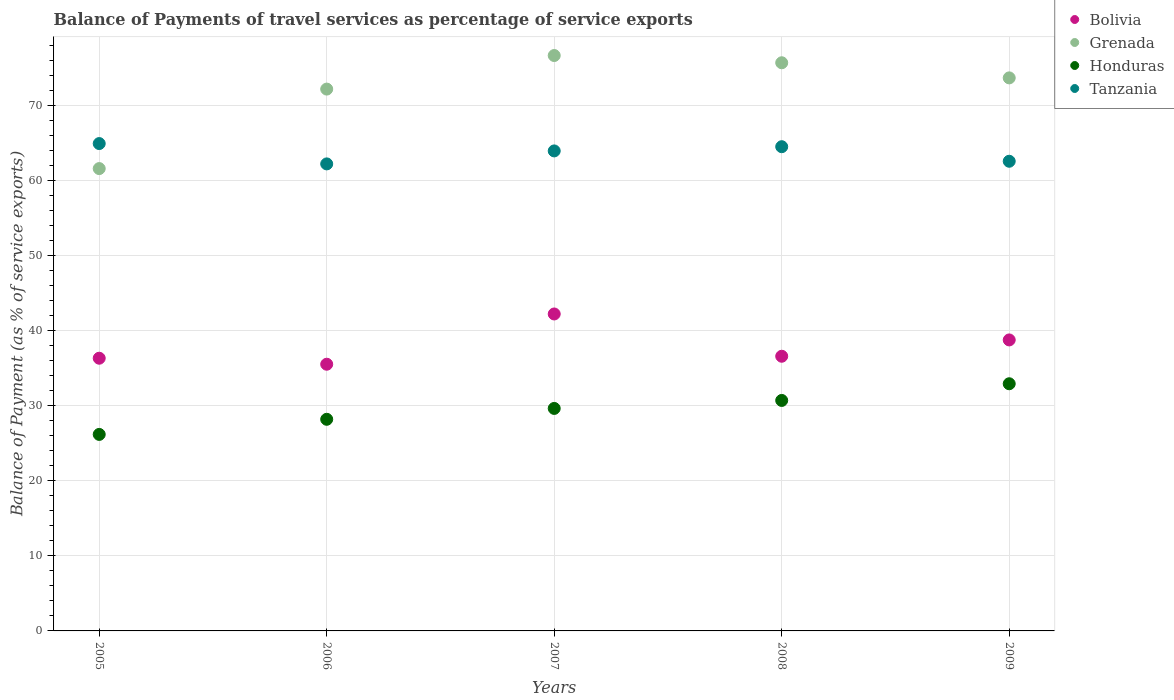What is the balance of payments of travel services in Bolivia in 2006?
Provide a short and direct response. 35.51. Across all years, what is the maximum balance of payments of travel services in Grenada?
Ensure brevity in your answer.  76.62. Across all years, what is the minimum balance of payments of travel services in Grenada?
Provide a short and direct response. 61.56. In which year was the balance of payments of travel services in Tanzania maximum?
Your answer should be very brief. 2005. In which year was the balance of payments of travel services in Honduras minimum?
Provide a short and direct response. 2005. What is the total balance of payments of travel services in Grenada in the graph?
Keep it short and to the point. 359.61. What is the difference between the balance of payments of travel services in Honduras in 2005 and that in 2008?
Keep it short and to the point. -4.52. What is the difference between the balance of payments of travel services in Honduras in 2006 and the balance of payments of travel services in Bolivia in 2005?
Provide a succinct answer. -8.13. What is the average balance of payments of travel services in Tanzania per year?
Provide a succinct answer. 63.6. In the year 2008, what is the difference between the balance of payments of travel services in Grenada and balance of payments of travel services in Honduras?
Ensure brevity in your answer.  44.96. What is the ratio of the balance of payments of travel services in Bolivia in 2006 to that in 2007?
Keep it short and to the point. 0.84. Is the balance of payments of travel services in Grenada in 2006 less than that in 2008?
Ensure brevity in your answer.  Yes. Is the difference between the balance of payments of travel services in Grenada in 2005 and 2006 greater than the difference between the balance of payments of travel services in Honduras in 2005 and 2006?
Your answer should be compact. No. What is the difference between the highest and the second highest balance of payments of travel services in Grenada?
Give a very brief answer. 0.96. What is the difference between the highest and the lowest balance of payments of travel services in Tanzania?
Your answer should be very brief. 2.71. Is the sum of the balance of payments of travel services in Grenada in 2006 and 2009 greater than the maximum balance of payments of travel services in Honduras across all years?
Give a very brief answer. Yes. Does the balance of payments of travel services in Bolivia monotonically increase over the years?
Provide a short and direct response. No. Is the balance of payments of travel services in Bolivia strictly greater than the balance of payments of travel services in Grenada over the years?
Your answer should be very brief. No. Is the balance of payments of travel services in Tanzania strictly less than the balance of payments of travel services in Honduras over the years?
Your response must be concise. No. How many dotlines are there?
Keep it short and to the point. 4. What is the difference between two consecutive major ticks on the Y-axis?
Keep it short and to the point. 10. Are the values on the major ticks of Y-axis written in scientific E-notation?
Ensure brevity in your answer.  No. Does the graph contain any zero values?
Keep it short and to the point. No. Does the graph contain grids?
Your response must be concise. Yes. Where does the legend appear in the graph?
Your answer should be very brief. Top right. How many legend labels are there?
Keep it short and to the point. 4. What is the title of the graph?
Ensure brevity in your answer.  Balance of Payments of travel services as percentage of service exports. What is the label or title of the Y-axis?
Provide a succinct answer. Balance of Payment (as % of service exports). What is the Balance of Payment (as % of service exports) in Bolivia in 2005?
Provide a succinct answer. 36.31. What is the Balance of Payment (as % of service exports) of Grenada in 2005?
Provide a succinct answer. 61.56. What is the Balance of Payment (as % of service exports) in Honduras in 2005?
Provide a short and direct response. 26.17. What is the Balance of Payment (as % of service exports) of Tanzania in 2005?
Make the answer very short. 64.89. What is the Balance of Payment (as % of service exports) in Bolivia in 2006?
Your answer should be compact. 35.51. What is the Balance of Payment (as % of service exports) of Grenada in 2006?
Ensure brevity in your answer.  72.14. What is the Balance of Payment (as % of service exports) in Honduras in 2006?
Make the answer very short. 28.18. What is the Balance of Payment (as % of service exports) in Tanzania in 2006?
Provide a succinct answer. 62.18. What is the Balance of Payment (as % of service exports) of Bolivia in 2007?
Give a very brief answer. 42.2. What is the Balance of Payment (as % of service exports) in Grenada in 2007?
Offer a terse response. 76.62. What is the Balance of Payment (as % of service exports) in Honduras in 2007?
Ensure brevity in your answer.  29.63. What is the Balance of Payment (as % of service exports) of Tanzania in 2007?
Provide a succinct answer. 63.91. What is the Balance of Payment (as % of service exports) of Bolivia in 2008?
Offer a terse response. 36.57. What is the Balance of Payment (as % of service exports) in Grenada in 2008?
Provide a short and direct response. 75.65. What is the Balance of Payment (as % of service exports) of Honduras in 2008?
Your answer should be compact. 30.69. What is the Balance of Payment (as % of service exports) of Tanzania in 2008?
Offer a terse response. 64.47. What is the Balance of Payment (as % of service exports) of Bolivia in 2009?
Your answer should be compact. 38.75. What is the Balance of Payment (as % of service exports) in Grenada in 2009?
Your answer should be compact. 73.64. What is the Balance of Payment (as % of service exports) in Honduras in 2009?
Make the answer very short. 32.91. What is the Balance of Payment (as % of service exports) in Tanzania in 2009?
Give a very brief answer. 62.54. Across all years, what is the maximum Balance of Payment (as % of service exports) of Bolivia?
Make the answer very short. 42.2. Across all years, what is the maximum Balance of Payment (as % of service exports) of Grenada?
Offer a terse response. 76.62. Across all years, what is the maximum Balance of Payment (as % of service exports) in Honduras?
Ensure brevity in your answer.  32.91. Across all years, what is the maximum Balance of Payment (as % of service exports) in Tanzania?
Give a very brief answer. 64.89. Across all years, what is the minimum Balance of Payment (as % of service exports) of Bolivia?
Offer a terse response. 35.51. Across all years, what is the minimum Balance of Payment (as % of service exports) in Grenada?
Give a very brief answer. 61.56. Across all years, what is the minimum Balance of Payment (as % of service exports) of Honduras?
Provide a short and direct response. 26.17. Across all years, what is the minimum Balance of Payment (as % of service exports) of Tanzania?
Your response must be concise. 62.18. What is the total Balance of Payment (as % of service exports) of Bolivia in the graph?
Offer a terse response. 189.34. What is the total Balance of Payment (as % of service exports) of Grenada in the graph?
Give a very brief answer. 359.61. What is the total Balance of Payment (as % of service exports) of Honduras in the graph?
Make the answer very short. 147.57. What is the total Balance of Payment (as % of service exports) in Tanzania in the graph?
Your answer should be very brief. 318. What is the difference between the Balance of Payment (as % of service exports) in Bolivia in 2005 and that in 2006?
Your answer should be very brief. 0.8. What is the difference between the Balance of Payment (as % of service exports) in Grenada in 2005 and that in 2006?
Your answer should be compact. -10.58. What is the difference between the Balance of Payment (as % of service exports) of Honduras in 2005 and that in 2006?
Offer a very short reply. -2.01. What is the difference between the Balance of Payment (as % of service exports) in Tanzania in 2005 and that in 2006?
Your answer should be compact. 2.71. What is the difference between the Balance of Payment (as % of service exports) of Bolivia in 2005 and that in 2007?
Your response must be concise. -5.89. What is the difference between the Balance of Payment (as % of service exports) in Grenada in 2005 and that in 2007?
Offer a terse response. -15.05. What is the difference between the Balance of Payment (as % of service exports) in Honduras in 2005 and that in 2007?
Your response must be concise. -3.46. What is the difference between the Balance of Payment (as % of service exports) of Tanzania in 2005 and that in 2007?
Make the answer very short. 0.98. What is the difference between the Balance of Payment (as % of service exports) in Bolivia in 2005 and that in 2008?
Provide a short and direct response. -0.26. What is the difference between the Balance of Payment (as % of service exports) of Grenada in 2005 and that in 2008?
Your answer should be very brief. -14.09. What is the difference between the Balance of Payment (as % of service exports) of Honduras in 2005 and that in 2008?
Offer a very short reply. -4.52. What is the difference between the Balance of Payment (as % of service exports) of Tanzania in 2005 and that in 2008?
Make the answer very short. 0.42. What is the difference between the Balance of Payment (as % of service exports) in Bolivia in 2005 and that in 2009?
Your response must be concise. -2.44. What is the difference between the Balance of Payment (as % of service exports) of Grenada in 2005 and that in 2009?
Offer a terse response. -12.08. What is the difference between the Balance of Payment (as % of service exports) in Honduras in 2005 and that in 2009?
Give a very brief answer. -6.75. What is the difference between the Balance of Payment (as % of service exports) in Tanzania in 2005 and that in 2009?
Ensure brevity in your answer.  2.36. What is the difference between the Balance of Payment (as % of service exports) in Bolivia in 2006 and that in 2007?
Your response must be concise. -6.69. What is the difference between the Balance of Payment (as % of service exports) of Grenada in 2006 and that in 2007?
Your response must be concise. -4.47. What is the difference between the Balance of Payment (as % of service exports) of Honduras in 2006 and that in 2007?
Offer a terse response. -1.45. What is the difference between the Balance of Payment (as % of service exports) in Tanzania in 2006 and that in 2007?
Make the answer very short. -1.73. What is the difference between the Balance of Payment (as % of service exports) of Bolivia in 2006 and that in 2008?
Offer a terse response. -1.06. What is the difference between the Balance of Payment (as % of service exports) in Grenada in 2006 and that in 2008?
Keep it short and to the point. -3.51. What is the difference between the Balance of Payment (as % of service exports) of Honduras in 2006 and that in 2008?
Your response must be concise. -2.51. What is the difference between the Balance of Payment (as % of service exports) in Tanzania in 2006 and that in 2008?
Your response must be concise. -2.29. What is the difference between the Balance of Payment (as % of service exports) of Bolivia in 2006 and that in 2009?
Make the answer very short. -3.24. What is the difference between the Balance of Payment (as % of service exports) in Grenada in 2006 and that in 2009?
Provide a short and direct response. -1.49. What is the difference between the Balance of Payment (as % of service exports) in Honduras in 2006 and that in 2009?
Ensure brevity in your answer.  -4.73. What is the difference between the Balance of Payment (as % of service exports) of Tanzania in 2006 and that in 2009?
Your response must be concise. -0.35. What is the difference between the Balance of Payment (as % of service exports) of Bolivia in 2007 and that in 2008?
Make the answer very short. 5.63. What is the difference between the Balance of Payment (as % of service exports) in Grenada in 2007 and that in 2008?
Give a very brief answer. 0.96. What is the difference between the Balance of Payment (as % of service exports) of Honduras in 2007 and that in 2008?
Make the answer very short. -1.06. What is the difference between the Balance of Payment (as % of service exports) in Tanzania in 2007 and that in 2008?
Your answer should be compact. -0.56. What is the difference between the Balance of Payment (as % of service exports) in Bolivia in 2007 and that in 2009?
Your answer should be compact. 3.46. What is the difference between the Balance of Payment (as % of service exports) of Grenada in 2007 and that in 2009?
Give a very brief answer. 2.98. What is the difference between the Balance of Payment (as % of service exports) in Honduras in 2007 and that in 2009?
Provide a succinct answer. -3.29. What is the difference between the Balance of Payment (as % of service exports) of Tanzania in 2007 and that in 2009?
Your response must be concise. 1.38. What is the difference between the Balance of Payment (as % of service exports) of Bolivia in 2008 and that in 2009?
Provide a succinct answer. -2.17. What is the difference between the Balance of Payment (as % of service exports) of Grenada in 2008 and that in 2009?
Your answer should be very brief. 2.01. What is the difference between the Balance of Payment (as % of service exports) in Honduras in 2008 and that in 2009?
Your answer should be very brief. -2.22. What is the difference between the Balance of Payment (as % of service exports) in Tanzania in 2008 and that in 2009?
Provide a succinct answer. 1.94. What is the difference between the Balance of Payment (as % of service exports) of Bolivia in 2005 and the Balance of Payment (as % of service exports) of Grenada in 2006?
Provide a short and direct response. -35.83. What is the difference between the Balance of Payment (as % of service exports) of Bolivia in 2005 and the Balance of Payment (as % of service exports) of Honduras in 2006?
Make the answer very short. 8.13. What is the difference between the Balance of Payment (as % of service exports) in Bolivia in 2005 and the Balance of Payment (as % of service exports) in Tanzania in 2006?
Offer a terse response. -25.87. What is the difference between the Balance of Payment (as % of service exports) of Grenada in 2005 and the Balance of Payment (as % of service exports) of Honduras in 2006?
Offer a terse response. 33.38. What is the difference between the Balance of Payment (as % of service exports) of Grenada in 2005 and the Balance of Payment (as % of service exports) of Tanzania in 2006?
Ensure brevity in your answer.  -0.62. What is the difference between the Balance of Payment (as % of service exports) of Honduras in 2005 and the Balance of Payment (as % of service exports) of Tanzania in 2006?
Give a very brief answer. -36.02. What is the difference between the Balance of Payment (as % of service exports) of Bolivia in 2005 and the Balance of Payment (as % of service exports) of Grenada in 2007?
Your response must be concise. -40.3. What is the difference between the Balance of Payment (as % of service exports) in Bolivia in 2005 and the Balance of Payment (as % of service exports) in Honduras in 2007?
Make the answer very short. 6.69. What is the difference between the Balance of Payment (as % of service exports) in Bolivia in 2005 and the Balance of Payment (as % of service exports) in Tanzania in 2007?
Ensure brevity in your answer.  -27.6. What is the difference between the Balance of Payment (as % of service exports) of Grenada in 2005 and the Balance of Payment (as % of service exports) of Honduras in 2007?
Ensure brevity in your answer.  31.94. What is the difference between the Balance of Payment (as % of service exports) of Grenada in 2005 and the Balance of Payment (as % of service exports) of Tanzania in 2007?
Provide a succinct answer. -2.35. What is the difference between the Balance of Payment (as % of service exports) in Honduras in 2005 and the Balance of Payment (as % of service exports) in Tanzania in 2007?
Give a very brief answer. -37.75. What is the difference between the Balance of Payment (as % of service exports) in Bolivia in 2005 and the Balance of Payment (as % of service exports) in Grenada in 2008?
Your response must be concise. -39.34. What is the difference between the Balance of Payment (as % of service exports) of Bolivia in 2005 and the Balance of Payment (as % of service exports) of Honduras in 2008?
Provide a succinct answer. 5.62. What is the difference between the Balance of Payment (as % of service exports) of Bolivia in 2005 and the Balance of Payment (as % of service exports) of Tanzania in 2008?
Provide a short and direct response. -28.16. What is the difference between the Balance of Payment (as % of service exports) in Grenada in 2005 and the Balance of Payment (as % of service exports) in Honduras in 2008?
Make the answer very short. 30.87. What is the difference between the Balance of Payment (as % of service exports) in Grenada in 2005 and the Balance of Payment (as % of service exports) in Tanzania in 2008?
Offer a terse response. -2.91. What is the difference between the Balance of Payment (as % of service exports) of Honduras in 2005 and the Balance of Payment (as % of service exports) of Tanzania in 2008?
Offer a very short reply. -38.31. What is the difference between the Balance of Payment (as % of service exports) in Bolivia in 2005 and the Balance of Payment (as % of service exports) in Grenada in 2009?
Ensure brevity in your answer.  -37.33. What is the difference between the Balance of Payment (as % of service exports) in Bolivia in 2005 and the Balance of Payment (as % of service exports) in Honduras in 2009?
Provide a short and direct response. 3.4. What is the difference between the Balance of Payment (as % of service exports) in Bolivia in 2005 and the Balance of Payment (as % of service exports) in Tanzania in 2009?
Your answer should be very brief. -26.23. What is the difference between the Balance of Payment (as % of service exports) in Grenada in 2005 and the Balance of Payment (as % of service exports) in Honduras in 2009?
Provide a short and direct response. 28.65. What is the difference between the Balance of Payment (as % of service exports) of Grenada in 2005 and the Balance of Payment (as % of service exports) of Tanzania in 2009?
Make the answer very short. -0.98. What is the difference between the Balance of Payment (as % of service exports) of Honduras in 2005 and the Balance of Payment (as % of service exports) of Tanzania in 2009?
Your answer should be compact. -36.37. What is the difference between the Balance of Payment (as % of service exports) in Bolivia in 2006 and the Balance of Payment (as % of service exports) in Grenada in 2007?
Your answer should be very brief. -41.1. What is the difference between the Balance of Payment (as % of service exports) of Bolivia in 2006 and the Balance of Payment (as % of service exports) of Honduras in 2007?
Offer a terse response. 5.89. What is the difference between the Balance of Payment (as % of service exports) in Bolivia in 2006 and the Balance of Payment (as % of service exports) in Tanzania in 2007?
Make the answer very short. -28.4. What is the difference between the Balance of Payment (as % of service exports) in Grenada in 2006 and the Balance of Payment (as % of service exports) in Honduras in 2007?
Offer a terse response. 42.52. What is the difference between the Balance of Payment (as % of service exports) in Grenada in 2006 and the Balance of Payment (as % of service exports) in Tanzania in 2007?
Provide a short and direct response. 8.23. What is the difference between the Balance of Payment (as % of service exports) in Honduras in 2006 and the Balance of Payment (as % of service exports) in Tanzania in 2007?
Ensure brevity in your answer.  -35.73. What is the difference between the Balance of Payment (as % of service exports) of Bolivia in 2006 and the Balance of Payment (as % of service exports) of Grenada in 2008?
Ensure brevity in your answer.  -40.14. What is the difference between the Balance of Payment (as % of service exports) of Bolivia in 2006 and the Balance of Payment (as % of service exports) of Honduras in 2008?
Your answer should be very brief. 4.82. What is the difference between the Balance of Payment (as % of service exports) of Bolivia in 2006 and the Balance of Payment (as % of service exports) of Tanzania in 2008?
Give a very brief answer. -28.96. What is the difference between the Balance of Payment (as % of service exports) in Grenada in 2006 and the Balance of Payment (as % of service exports) in Honduras in 2008?
Provide a short and direct response. 41.46. What is the difference between the Balance of Payment (as % of service exports) in Grenada in 2006 and the Balance of Payment (as % of service exports) in Tanzania in 2008?
Provide a short and direct response. 7.67. What is the difference between the Balance of Payment (as % of service exports) of Honduras in 2006 and the Balance of Payment (as % of service exports) of Tanzania in 2008?
Make the answer very short. -36.3. What is the difference between the Balance of Payment (as % of service exports) of Bolivia in 2006 and the Balance of Payment (as % of service exports) of Grenada in 2009?
Offer a terse response. -38.13. What is the difference between the Balance of Payment (as % of service exports) in Bolivia in 2006 and the Balance of Payment (as % of service exports) in Honduras in 2009?
Give a very brief answer. 2.6. What is the difference between the Balance of Payment (as % of service exports) in Bolivia in 2006 and the Balance of Payment (as % of service exports) in Tanzania in 2009?
Your answer should be very brief. -27.03. What is the difference between the Balance of Payment (as % of service exports) in Grenada in 2006 and the Balance of Payment (as % of service exports) in Honduras in 2009?
Give a very brief answer. 39.23. What is the difference between the Balance of Payment (as % of service exports) in Grenada in 2006 and the Balance of Payment (as % of service exports) in Tanzania in 2009?
Offer a very short reply. 9.61. What is the difference between the Balance of Payment (as % of service exports) of Honduras in 2006 and the Balance of Payment (as % of service exports) of Tanzania in 2009?
Your response must be concise. -34.36. What is the difference between the Balance of Payment (as % of service exports) in Bolivia in 2007 and the Balance of Payment (as % of service exports) in Grenada in 2008?
Keep it short and to the point. -33.45. What is the difference between the Balance of Payment (as % of service exports) in Bolivia in 2007 and the Balance of Payment (as % of service exports) in Honduras in 2008?
Make the answer very short. 11.51. What is the difference between the Balance of Payment (as % of service exports) of Bolivia in 2007 and the Balance of Payment (as % of service exports) of Tanzania in 2008?
Offer a terse response. -22.27. What is the difference between the Balance of Payment (as % of service exports) of Grenada in 2007 and the Balance of Payment (as % of service exports) of Honduras in 2008?
Your response must be concise. 45.93. What is the difference between the Balance of Payment (as % of service exports) in Grenada in 2007 and the Balance of Payment (as % of service exports) in Tanzania in 2008?
Offer a very short reply. 12.14. What is the difference between the Balance of Payment (as % of service exports) in Honduras in 2007 and the Balance of Payment (as % of service exports) in Tanzania in 2008?
Ensure brevity in your answer.  -34.85. What is the difference between the Balance of Payment (as % of service exports) of Bolivia in 2007 and the Balance of Payment (as % of service exports) of Grenada in 2009?
Offer a very short reply. -31.44. What is the difference between the Balance of Payment (as % of service exports) in Bolivia in 2007 and the Balance of Payment (as % of service exports) in Honduras in 2009?
Give a very brief answer. 9.29. What is the difference between the Balance of Payment (as % of service exports) in Bolivia in 2007 and the Balance of Payment (as % of service exports) in Tanzania in 2009?
Provide a short and direct response. -20.33. What is the difference between the Balance of Payment (as % of service exports) in Grenada in 2007 and the Balance of Payment (as % of service exports) in Honduras in 2009?
Offer a terse response. 43.7. What is the difference between the Balance of Payment (as % of service exports) of Grenada in 2007 and the Balance of Payment (as % of service exports) of Tanzania in 2009?
Your answer should be compact. 14.08. What is the difference between the Balance of Payment (as % of service exports) of Honduras in 2007 and the Balance of Payment (as % of service exports) of Tanzania in 2009?
Provide a short and direct response. -32.91. What is the difference between the Balance of Payment (as % of service exports) in Bolivia in 2008 and the Balance of Payment (as % of service exports) in Grenada in 2009?
Offer a terse response. -37.06. What is the difference between the Balance of Payment (as % of service exports) of Bolivia in 2008 and the Balance of Payment (as % of service exports) of Honduras in 2009?
Provide a succinct answer. 3.66. What is the difference between the Balance of Payment (as % of service exports) of Bolivia in 2008 and the Balance of Payment (as % of service exports) of Tanzania in 2009?
Your answer should be very brief. -25.96. What is the difference between the Balance of Payment (as % of service exports) in Grenada in 2008 and the Balance of Payment (as % of service exports) in Honduras in 2009?
Your answer should be compact. 42.74. What is the difference between the Balance of Payment (as % of service exports) of Grenada in 2008 and the Balance of Payment (as % of service exports) of Tanzania in 2009?
Offer a very short reply. 13.11. What is the difference between the Balance of Payment (as % of service exports) in Honduras in 2008 and the Balance of Payment (as % of service exports) in Tanzania in 2009?
Your answer should be very brief. -31.85. What is the average Balance of Payment (as % of service exports) in Bolivia per year?
Your response must be concise. 37.87. What is the average Balance of Payment (as % of service exports) in Grenada per year?
Your response must be concise. 71.92. What is the average Balance of Payment (as % of service exports) in Honduras per year?
Your response must be concise. 29.51. What is the average Balance of Payment (as % of service exports) of Tanzania per year?
Offer a very short reply. 63.6. In the year 2005, what is the difference between the Balance of Payment (as % of service exports) of Bolivia and Balance of Payment (as % of service exports) of Grenada?
Ensure brevity in your answer.  -25.25. In the year 2005, what is the difference between the Balance of Payment (as % of service exports) in Bolivia and Balance of Payment (as % of service exports) in Honduras?
Provide a short and direct response. 10.15. In the year 2005, what is the difference between the Balance of Payment (as % of service exports) of Bolivia and Balance of Payment (as % of service exports) of Tanzania?
Provide a short and direct response. -28.58. In the year 2005, what is the difference between the Balance of Payment (as % of service exports) of Grenada and Balance of Payment (as % of service exports) of Honduras?
Make the answer very short. 35.4. In the year 2005, what is the difference between the Balance of Payment (as % of service exports) of Grenada and Balance of Payment (as % of service exports) of Tanzania?
Offer a very short reply. -3.33. In the year 2005, what is the difference between the Balance of Payment (as % of service exports) of Honduras and Balance of Payment (as % of service exports) of Tanzania?
Your response must be concise. -38.73. In the year 2006, what is the difference between the Balance of Payment (as % of service exports) of Bolivia and Balance of Payment (as % of service exports) of Grenada?
Your answer should be compact. -36.63. In the year 2006, what is the difference between the Balance of Payment (as % of service exports) in Bolivia and Balance of Payment (as % of service exports) in Honduras?
Give a very brief answer. 7.33. In the year 2006, what is the difference between the Balance of Payment (as % of service exports) in Bolivia and Balance of Payment (as % of service exports) in Tanzania?
Keep it short and to the point. -26.67. In the year 2006, what is the difference between the Balance of Payment (as % of service exports) in Grenada and Balance of Payment (as % of service exports) in Honduras?
Ensure brevity in your answer.  43.97. In the year 2006, what is the difference between the Balance of Payment (as % of service exports) in Grenada and Balance of Payment (as % of service exports) in Tanzania?
Offer a terse response. 9.96. In the year 2006, what is the difference between the Balance of Payment (as % of service exports) of Honduras and Balance of Payment (as % of service exports) of Tanzania?
Make the answer very short. -34.01. In the year 2007, what is the difference between the Balance of Payment (as % of service exports) of Bolivia and Balance of Payment (as % of service exports) of Grenada?
Your response must be concise. -34.41. In the year 2007, what is the difference between the Balance of Payment (as % of service exports) of Bolivia and Balance of Payment (as % of service exports) of Honduras?
Provide a short and direct response. 12.58. In the year 2007, what is the difference between the Balance of Payment (as % of service exports) in Bolivia and Balance of Payment (as % of service exports) in Tanzania?
Provide a short and direct response. -21.71. In the year 2007, what is the difference between the Balance of Payment (as % of service exports) in Grenada and Balance of Payment (as % of service exports) in Honduras?
Your answer should be compact. 46.99. In the year 2007, what is the difference between the Balance of Payment (as % of service exports) of Grenada and Balance of Payment (as % of service exports) of Tanzania?
Offer a very short reply. 12.7. In the year 2007, what is the difference between the Balance of Payment (as % of service exports) in Honduras and Balance of Payment (as % of service exports) in Tanzania?
Ensure brevity in your answer.  -34.29. In the year 2008, what is the difference between the Balance of Payment (as % of service exports) of Bolivia and Balance of Payment (as % of service exports) of Grenada?
Your response must be concise. -39.08. In the year 2008, what is the difference between the Balance of Payment (as % of service exports) in Bolivia and Balance of Payment (as % of service exports) in Honduras?
Your response must be concise. 5.88. In the year 2008, what is the difference between the Balance of Payment (as % of service exports) of Bolivia and Balance of Payment (as % of service exports) of Tanzania?
Provide a succinct answer. -27.9. In the year 2008, what is the difference between the Balance of Payment (as % of service exports) of Grenada and Balance of Payment (as % of service exports) of Honduras?
Give a very brief answer. 44.96. In the year 2008, what is the difference between the Balance of Payment (as % of service exports) of Grenada and Balance of Payment (as % of service exports) of Tanzania?
Make the answer very short. 11.18. In the year 2008, what is the difference between the Balance of Payment (as % of service exports) in Honduras and Balance of Payment (as % of service exports) in Tanzania?
Keep it short and to the point. -33.79. In the year 2009, what is the difference between the Balance of Payment (as % of service exports) of Bolivia and Balance of Payment (as % of service exports) of Grenada?
Make the answer very short. -34.89. In the year 2009, what is the difference between the Balance of Payment (as % of service exports) of Bolivia and Balance of Payment (as % of service exports) of Honduras?
Provide a succinct answer. 5.83. In the year 2009, what is the difference between the Balance of Payment (as % of service exports) in Bolivia and Balance of Payment (as % of service exports) in Tanzania?
Offer a very short reply. -23.79. In the year 2009, what is the difference between the Balance of Payment (as % of service exports) in Grenada and Balance of Payment (as % of service exports) in Honduras?
Offer a very short reply. 40.73. In the year 2009, what is the difference between the Balance of Payment (as % of service exports) of Grenada and Balance of Payment (as % of service exports) of Tanzania?
Ensure brevity in your answer.  11.1. In the year 2009, what is the difference between the Balance of Payment (as % of service exports) of Honduras and Balance of Payment (as % of service exports) of Tanzania?
Provide a succinct answer. -29.63. What is the ratio of the Balance of Payment (as % of service exports) of Bolivia in 2005 to that in 2006?
Offer a very short reply. 1.02. What is the ratio of the Balance of Payment (as % of service exports) of Grenada in 2005 to that in 2006?
Make the answer very short. 0.85. What is the ratio of the Balance of Payment (as % of service exports) in Honduras in 2005 to that in 2006?
Keep it short and to the point. 0.93. What is the ratio of the Balance of Payment (as % of service exports) of Tanzania in 2005 to that in 2006?
Your answer should be very brief. 1.04. What is the ratio of the Balance of Payment (as % of service exports) of Bolivia in 2005 to that in 2007?
Provide a short and direct response. 0.86. What is the ratio of the Balance of Payment (as % of service exports) of Grenada in 2005 to that in 2007?
Make the answer very short. 0.8. What is the ratio of the Balance of Payment (as % of service exports) in Honduras in 2005 to that in 2007?
Your answer should be very brief. 0.88. What is the ratio of the Balance of Payment (as % of service exports) of Tanzania in 2005 to that in 2007?
Ensure brevity in your answer.  1.02. What is the ratio of the Balance of Payment (as % of service exports) of Bolivia in 2005 to that in 2008?
Provide a short and direct response. 0.99. What is the ratio of the Balance of Payment (as % of service exports) of Grenada in 2005 to that in 2008?
Your response must be concise. 0.81. What is the ratio of the Balance of Payment (as % of service exports) in Honduras in 2005 to that in 2008?
Provide a short and direct response. 0.85. What is the ratio of the Balance of Payment (as % of service exports) of Bolivia in 2005 to that in 2009?
Your answer should be compact. 0.94. What is the ratio of the Balance of Payment (as % of service exports) in Grenada in 2005 to that in 2009?
Offer a terse response. 0.84. What is the ratio of the Balance of Payment (as % of service exports) in Honduras in 2005 to that in 2009?
Give a very brief answer. 0.8. What is the ratio of the Balance of Payment (as % of service exports) of Tanzania in 2005 to that in 2009?
Offer a terse response. 1.04. What is the ratio of the Balance of Payment (as % of service exports) of Bolivia in 2006 to that in 2007?
Offer a very short reply. 0.84. What is the ratio of the Balance of Payment (as % of service exports) of Grenada in 2006 to that in 2007?
Offer a very short reply. 0.94. What is the ratio of the Balance of Payment (as % of service exports) of Honduras in 2006 to that in 2007?
Provide a succinct answer. 0.95. What is the ratio of the Balance of Payment (as % of service exports) of Grenada in 2006 to that in 2008?
Your response must be concise. 0.95. What is the ratio of the Balance of Payment (as % of service exports) of Honduras in 2006 to that in 2008?
Give a very brief answer. 0.92. What is the ratio of the Balance of Payment (as % of service exports) in Tanzania in 2006 to that in 2008?
Give a very brief answer. 0.96. What is the ratio of the Balance of Payment (as % of service exports) of Bolivia in 2006 to that in 2009?
Your answer should be compact. 0.92. What is the ratio of the Balance of Payment (as % of service exports) in Grenada in 2006 to that in 2009?
Ensure brevity in your answer.  0.98. What is the ratio of the Balance of Payment (as % of service exports) in Honduras in 2006 to that in 2009?
Offer a very short reply. 0.86. What is the ratio of the Balance of Payment (as % of service exports) of Bolivia in 2007 to that in 2008?
Give a very brief answer. 1.15. What is the ratio of the Balance of Payment (as % of service exports) of Grenada in 2007 to that in 2008?
Your response must be concise. 1.01. What is the ratio of the Balance of Payment (as % of service exports) in Honduras in 2007 to that in 2008?
Keep it short and to the point. 0.97. What is the ratio of the Balance of Payment (as % of service exports) of Bolivia in 2007 to that in 2009?
Provide a succinct answer. 1.09. What is the ratio of the Balance of Payment (as % of service exports) in Grenada in 2007 to that in 2009?
Give a very brief answer. 1.04. What is the ratio of the Balance of Payment (as % of service exports) in Honduras in 2007 to that in 2009?
Keep it short and to the point. 0.9. What is the ratio of the Balance of Payment (as % of service exports) of Bolivia in 2008 to that in 2009?
Provide a short and direct response. 0.94. What is the ratio of the Balance of Payment (as % of service exports) in Grenada in 2008 to that in 2009?
Give a very brief answer. 1.03. What is the ratio of the Balance of Payment (as % of service exports) in Honduras in 2008 to that in 2009?
Provide a succinct answer. 0.93. What is the ratio of the Balance of Payment (as % of service exports) in Tanzania in 2008 to that in 2009?
Your response must be concise. 1.03. What is the difference between the highest and the second highest Balance of Payment (as % of service exports) of Bolivia?
Give a very brief answer. 3.46. What is the difference between the highest and the second highest Balance of Payment (as % of service exports) of Grenada?
Offer a terse response. 0.96. What is the difference between the highest and the second highest Balance of Payment (as % of service exports) of Honduras?
Keep it short and to the point. 2.22. What is the difference between the highest and the second highest Balance of Payment (as % of service exports) of Tanzania?
Keep it short and to the point. 0.42. What is the difference between the highest and the lowest Balance of Payment (as % of service exports) of Bolivia?
Your answer should be very brief. 6.69. What is the difference between the highest and the lowest Balance of Payment (as % of service exports) of Grenada?
Make the answer very short. 15.05. What is the difference between the highest and the lowest Balance of Payment (as % of service exports) of Honduras?
Your answer should be compact. 6.75. What is the difference between the highest and the lowest Balance of Payment (as % of service exports) in Tanzania?
Provide a succinct answer. 2.71. 